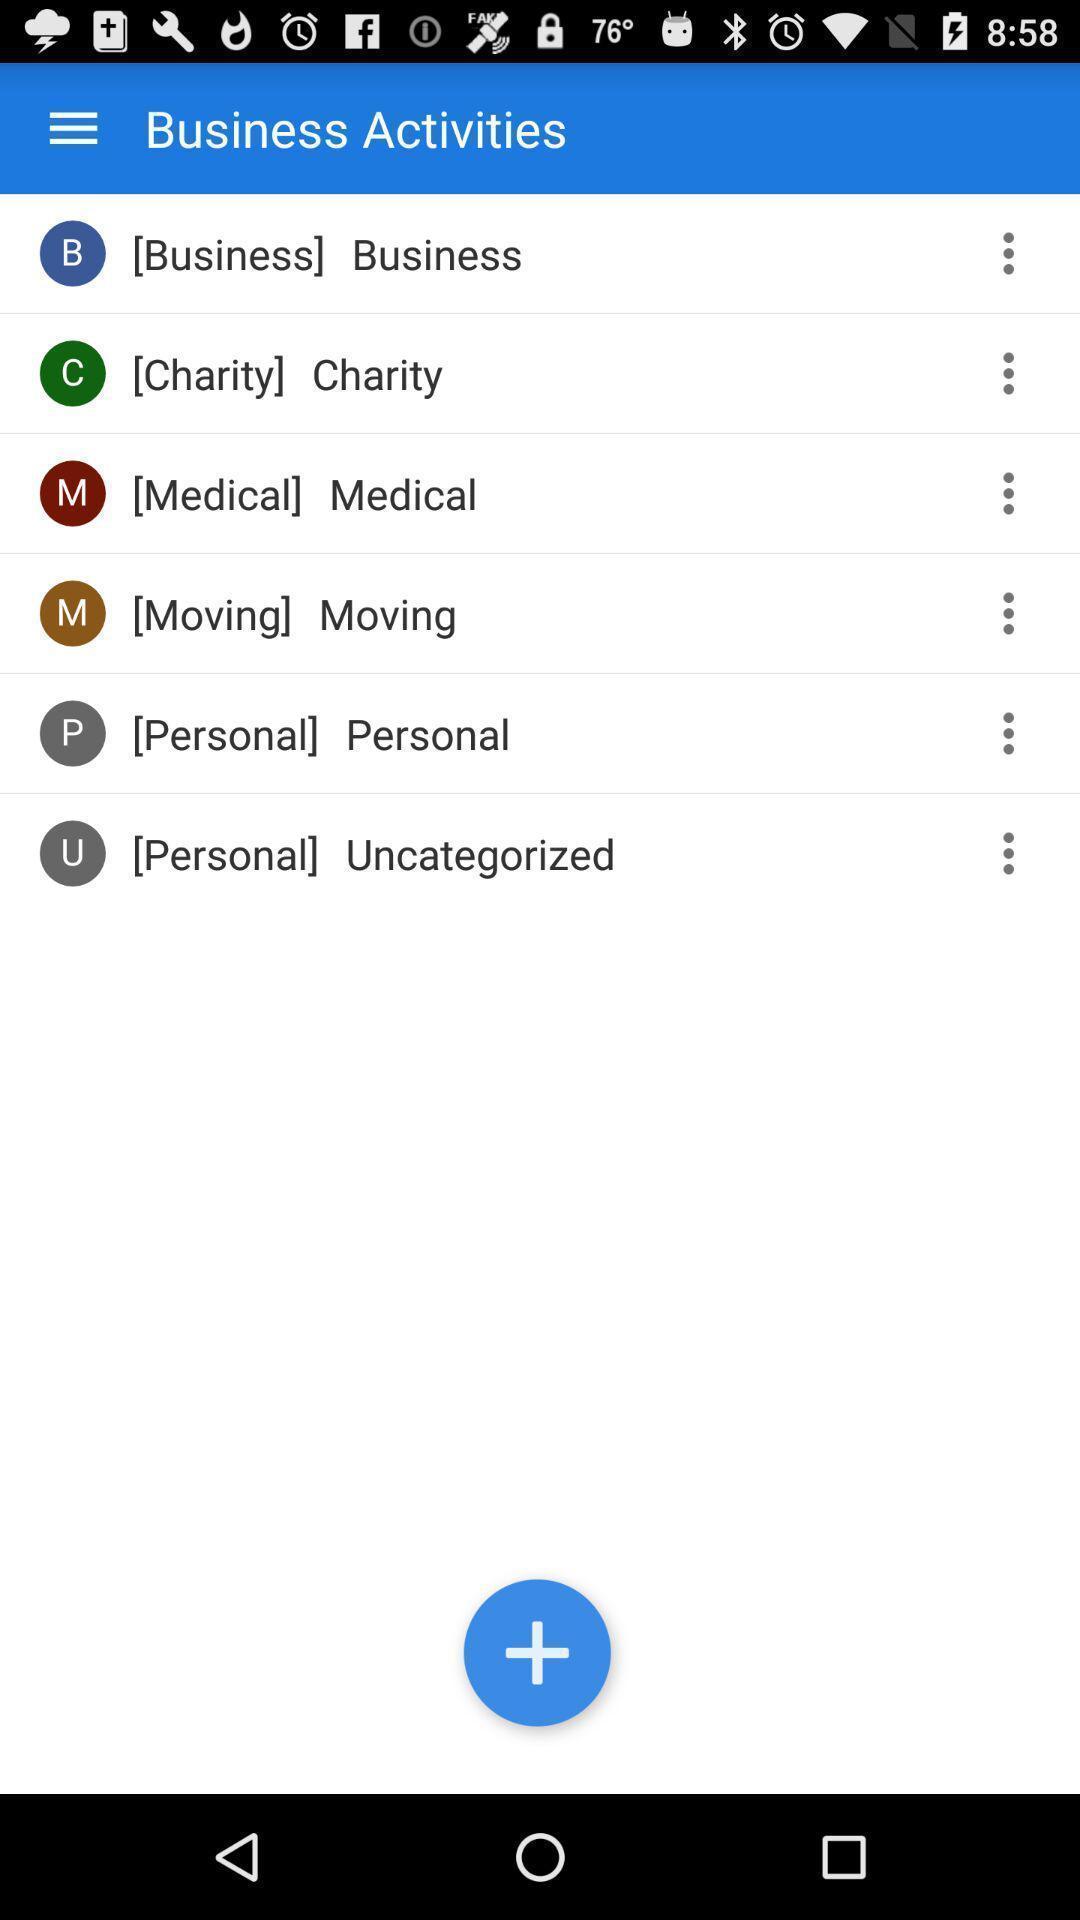Give me a narrative description of this picture. Screen showing list of activities. 